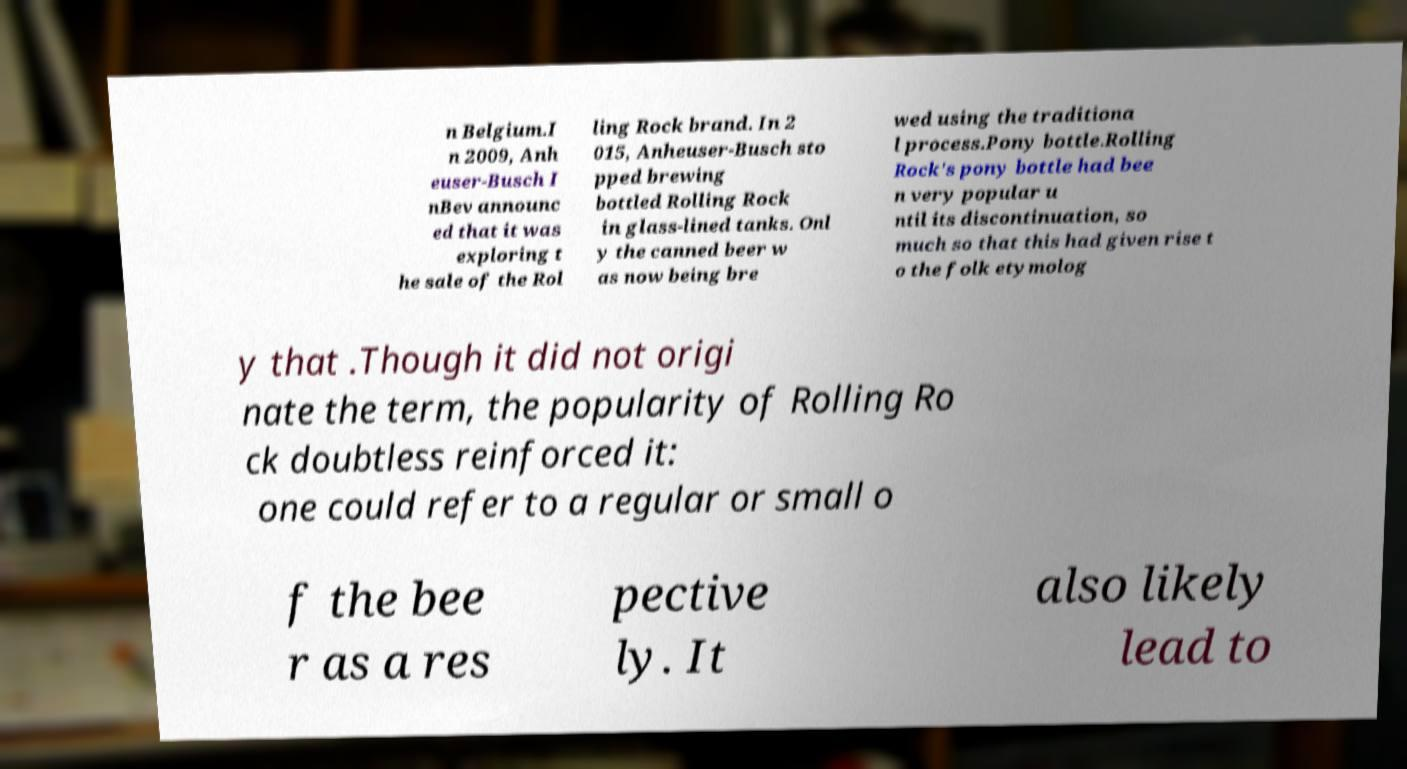Can you read and provide the text displayed in the image?This photo seems to have some interesting text. Can you extract and type it out for me? n Belgium.I n 2009, Anh euser-Busch I nBev announc ed that it was exploring t he sale of the Rol ling Rock brand. In 2 015, Anheuser-Busch sto pped brewing bottled Rolling Rock in glass-lined tanks. Onl y the canned beer w as now being bre wed using the traditiona l process.Pony bottle.Rolling Rock's pony bottle had bee n very popular u ntil its discontinuation, so much so that this had given rise t o the folk etymolog y that .Though it did not origi nate the term, the popularity of Rolling Ro ck doubtless reinforced it: one could refer to a regular or small o f the bee r as a res pective ly. It also likely lead to 